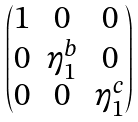<formula> <loc_0><loc_0><loc_500><loc_500>\begin{pmatrix} 1 & 0 & 0 \\ 0 & \eta _ { 1 } ^ { b } & 0 \\ 0 & 0 & \eta _ { 1 } ^ { c } \end{pmatrix}</formula> 